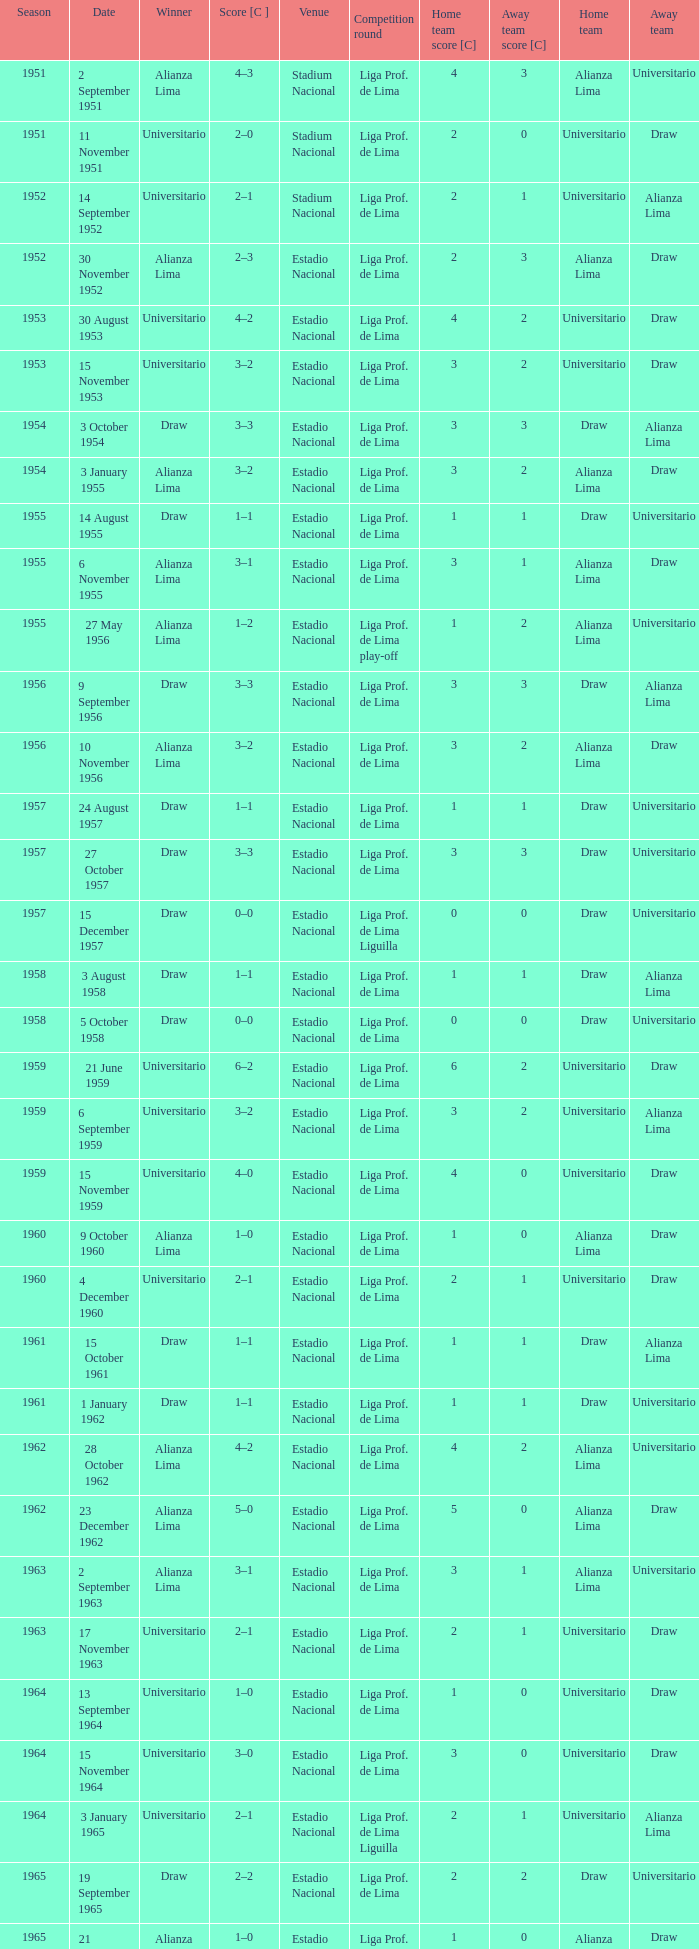Would you mind parsing the complete table? {'header': ['Season', 'Date', 'Winner', 'Score [C ]', 'Venue', 'Competition round', 'Home team score [C]', 'Away team score [C]', 'Home team', 'Away team'], 'rows': [['1951', '2 September 1951', 'Alianza Lima', '4–3', 'Stadium Nacional', 'Liga Prof. de Lima', '4', '3', 'Alianza Lima', 'Universitario'], ['1951', '11 November 1951', 'Universitario', '2–0', 'Stadium Nacional', 'Liga Prof. de Lima', '2', '0', 'Universitario', 'Draw'], ['1952', '14 September 1952', 'Universitario', '2–1', 'Stadium Nacional', 'Liga Prof. de Lima', '2', '1', 'Universitario', 'Alianza Lima'], ['1952', '30 November 1952', 'Alianza Lima', '2–3', 'Estadio Nacional', 'Liga Prof. de Lima', '2', '3', 'Alianza Lima', 'Draw'], ['1953', '30 August 1953', 'Universitario', '4–2', 'Estadio Nacional', 'Liga Prof. de Lima', '4', '2', 'Universitario', 'Draw'], ['1953', '15 November 1953', 'Universitario', '3–2', 'Estadio Nacional', 'Liga Prof. de Lima', '3', '2', 'Universitario', 'Draw'], ['1954', '3 October 1954', 'Draw', '3–3', 'Estadio Nacional', 'Liga Prof. de Lima', '3', '3', 'Draw', 'Alianza Lima'], ['1954', '3 January 1955', 'Alianza Lima', '3–2', 'Estadio Nacional', 'Liga Prof. de Lima', '3', '2', 'Alianza Lima', 'Draw'], ['1955', '14 August 1955', 'Draw', '1–1', 'Estadio Nacional', 'Liga Prof. de Lima', '1', '1', 'Draw', 'Universitario'], ['1955', '6 November 1955', 'Alianza Lima', '3–1', 'Estadio Nacional', 'Liga Prof. de Lima', '3', '1', 'Alianza Lima', 'Draw'], ['1955', '27 May 1956', 'Alianza Lima', '1–2', 'Estadio Nacional', 'Liga Prof. de Lima play-off', '1', '2', 'Alianza Lima', 'Universitario'], ['1956', '9 September 1956', 'Draw', '3–3', 'Estadio Nacional', 'Liga Prof. de Lima', '3', '3', 'Draw', 'Alianza Lima'], ['1956', '10 November 1956', 'Alianza Lima', '3–2', 'Estadio Nacional', 'Liga Prof. de Lima', '3', '2', 'Alianza Lima', 'Draw'], ['1957', '24 August 1957', 'Draw', '1–1', 'Estadio Nacional', 'Liga Prof. de Lima', '1', '1', 'Draw', 'Universitario'], ['1957', '27 October 1957', 'Draw', '3–3', 'Estadio Nacional', 'Liga Prof. de Lima', '3', '3', 'Draw', 'Universitario'], ['1957', '15 December 1957', 'Draw', '0–0', 'Estadio Nacional', 'Liga Prof. de Lima Liguilla', '0', '0', 'Draw', 'Universitario'], ['1958', '3 August 1958', 'Draw', '1–1', 'Estadio Nacional', 'Liga Prof. de Lima', '1', '1', 'Draw', 'Alianza Lima'], ['1958', '5 October 1958', 'Draw', '0–0', 'Estadio Nacional', 'Liga Prof. de Lima', '0', '0', 'Draw', 'Universitario'], ['1959', '21 June 1959', 'Universitario', '6–2', 'Estadio Nacional', 'Liga Prof. de Lima', '6', '2', 'Universitario', 'Draw'], ['1959', '6 September 1959', 'Universitario', '3–2', 'Estadio Nacional', 'Liga Prof. de Lima', '3', '2', 'Universitario', 'Alianza Lima'], ['1959', '15 November 1959', 'Universitario', '4–0', 'Estadio Nacional', 'Liga Prof. de Lima', '4', '0', 'Universitario', 'Draw'], ['1960', '9 October 1960', 'Alianza Lima', '1–0', 'Estadio Nacional', 'Liga Prof. de Lima', '1', '0', 'Alianza Lima', 'Draw'], ['1960', '4 December 1960', 'Universitario', '2–1', 'Estadio Nacional', 'Liga Prof. de Lima', '2', '1', 'Universitario', 'Draw'], ['1961', '15 October 1961', 'Draw', '1–1', 'Estadio Nacional', 'Liga Prof. de Lima', '1', '1', 'Draw', 'Alianza Lima'], ['1961', '1 January 1962', 'Draw', '1–1', 'Estadio Nacional', 'Liga Prof. de Lima', '1', '1', 'Draw', 'Universitario'], ['1962', '28 October 1962', 'Alianza Lima', '4–2', 'Estadio Nacional', 'Liga Prof. de Lima', '4', '2', 'Alianza Lima', 'Universitario'], ['1962', '23 December 1962', 'Alianza Lima', '5–0', 'Estadio Nacional', 'Liga Prof. de Lima', '5', '0', 'Alianza Lima', 'Draw'], ['1963', '2 September 1963', 'Alianza Lima', '3–1', 'Estadio Nacional', 'Liga Prof. de Lima', '3', '1', 'Alianza Lima', 'Universitario'], ['1963', '17 November 1963', 'Universitario', '2–1', 'Estadio Nacional', 'Liga Prof. de Lima', '2', '1', 'Universitario', 'Draw'], ['1964', '13 September 1964', 'Universitario', '1–0', 'Estadio Nacional', 'Liga Prof. de Lima', '1', '0', 'Universitario', 'Draw'], ['1964', '15 November 1964', 'Universitario', '3–0', 'Estadio Nacional', 'Liga Prof. de Lima', '3', '0', 'Universitario', 'Draw'], ['1964', '3 January 1965', 'Universitario', '2–1', 'Estadio Nacional', 'Liga Prof. de Lima Liguilla', '2', '1', 'Universitario', 'Alianza Lima'], ['1965', '19 September 1965', 'Draw', '2–2', 'Estadio Nacional', 'Liga Prof. de Lima', '2', '2', 'Draw', 'Universitario'], ['1965', '21 November 1965', 'Alianza Lima', '1–0', 'Estadio Nacional', 'Liga Prof. de Lima', '1', '0', 'Alianza Lima', 'Draw'], ['1965', '19 December 1965', 'Universitario', '1–0', 'Estadio Nacional', 'Liga Prof. de Lima Liguilla', '1', '0', 'Universitario', 'Alianza Lima']]} During the 1965 competition that alianza lima won, what was the score? 1–0. 